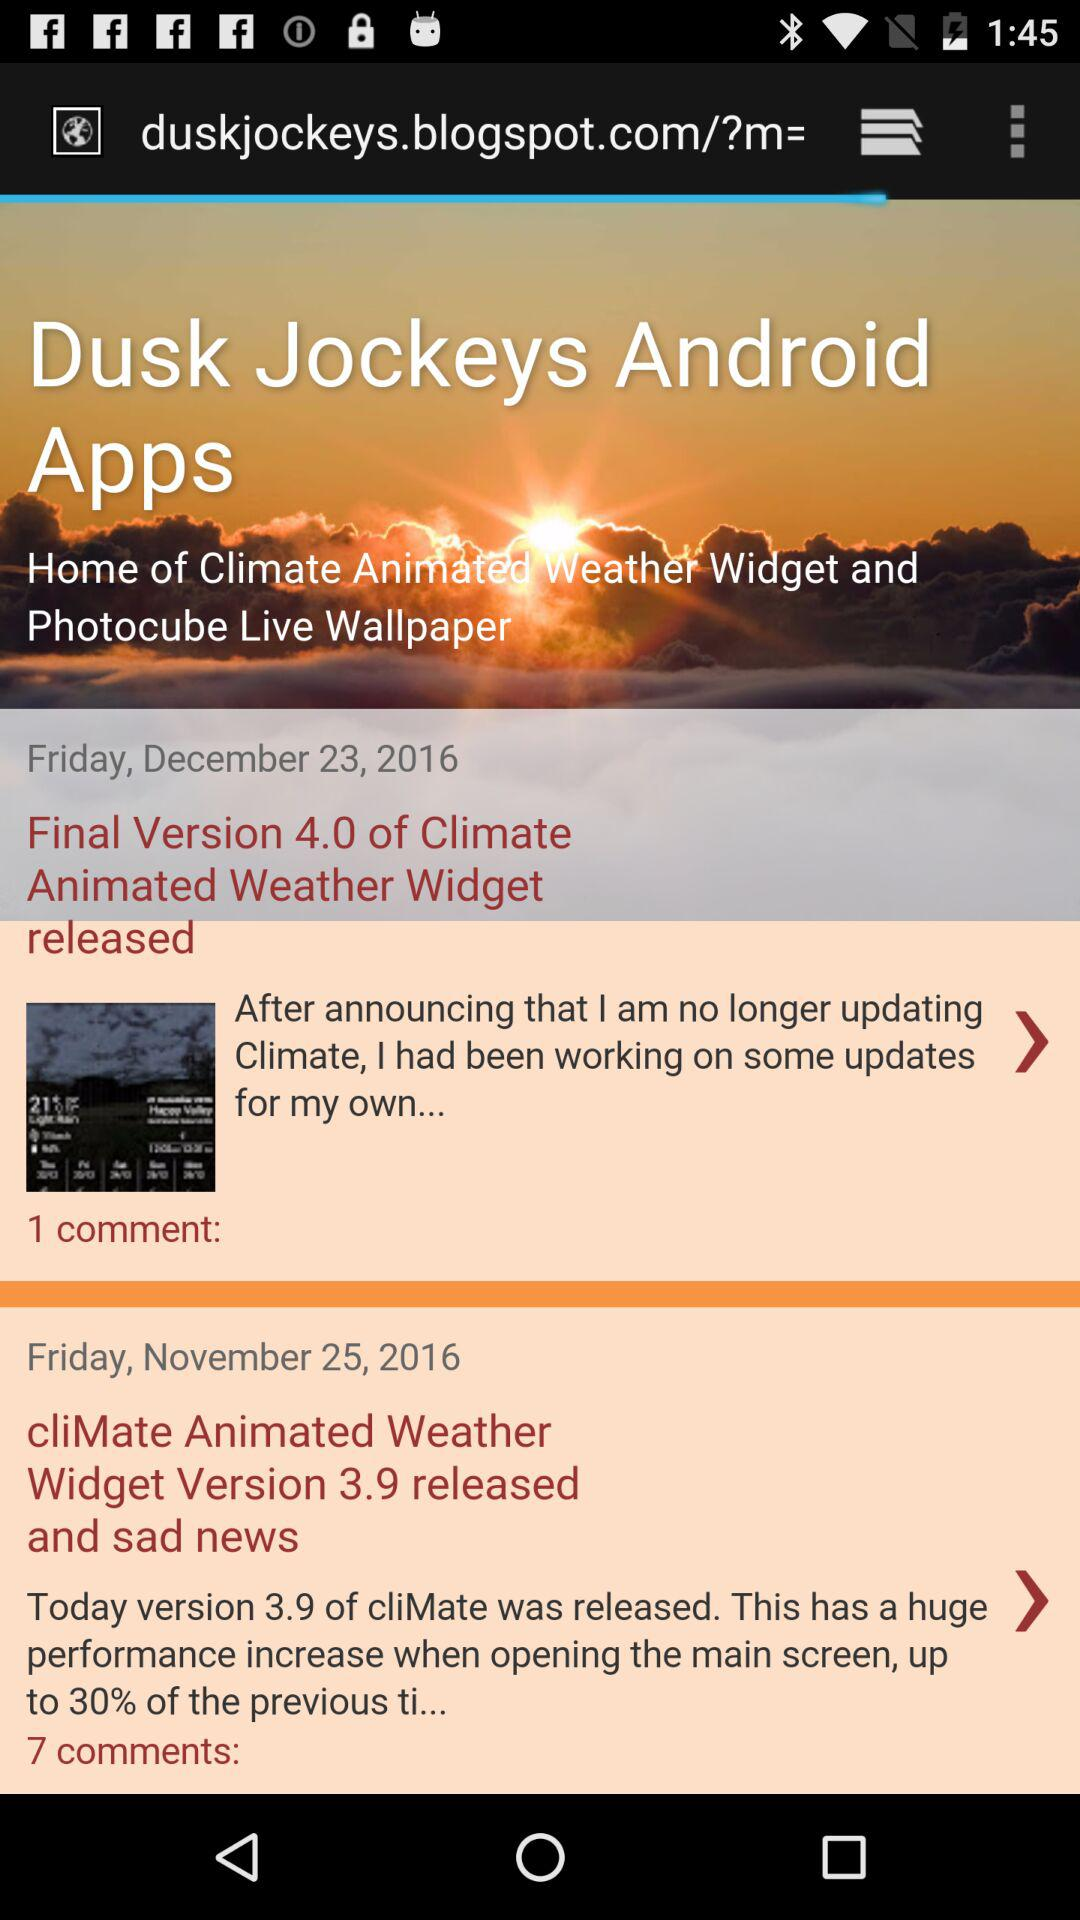What is the release date of the final version 4.0? The release date of the final version 4.0 is Friday, December 23, 2016. 